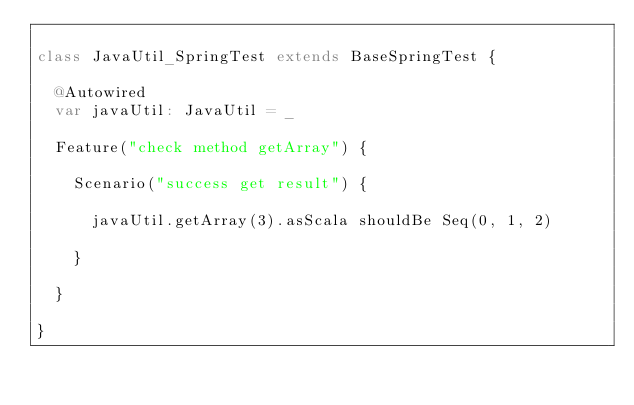<code> <loc_0><loc_0><loc_500><loc_500><_Scala_>
class JavaUtil_SpringTest extends BaseSpringTest {

  @Autowired
  var javaUtil: JavaUtil = _

  Feature("check method getArray") {

    Scenario("success get result") {
      
      javaUtil.getArray(3).asScala shouldBe Seq(0, 1, 2)

    }

  }

}
</code> 